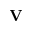<formula> <loc_0><loc_0><loc_500><loc_500>V</formula> 